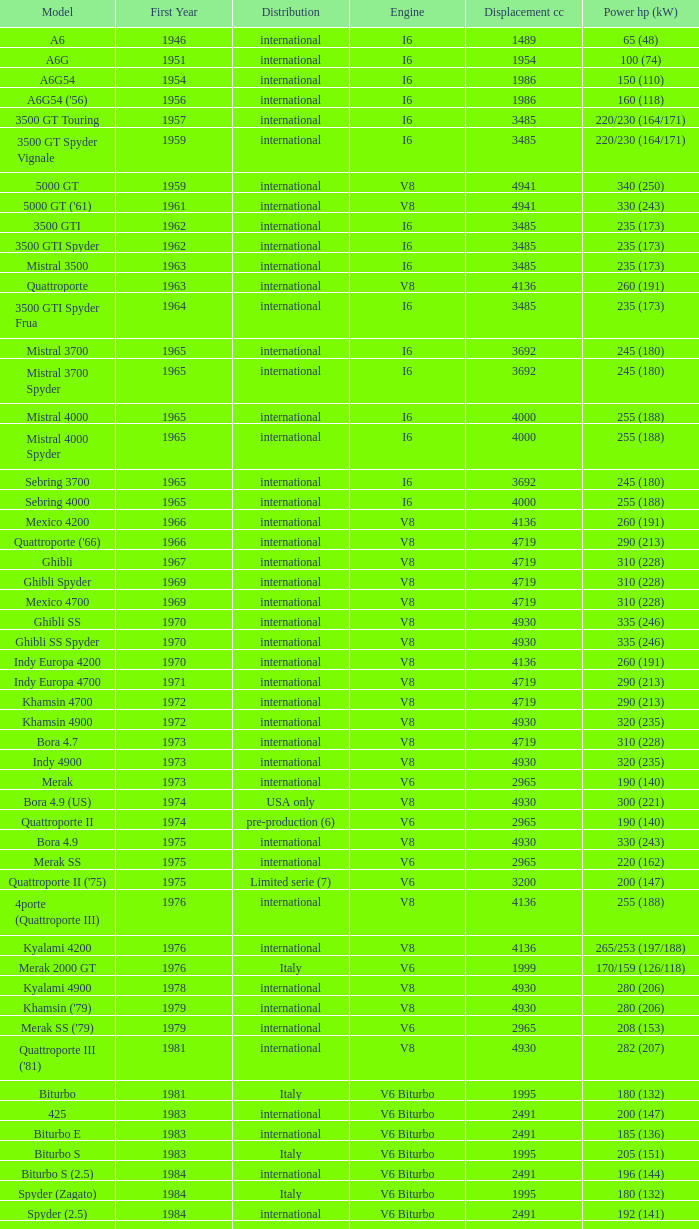What is the lowest First Year, when Model is "Quattroporte (2.8)"? 1994.0. 